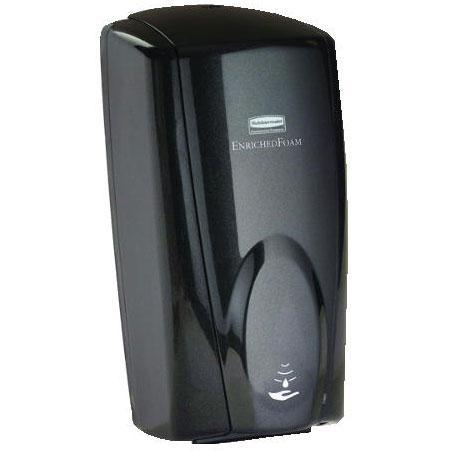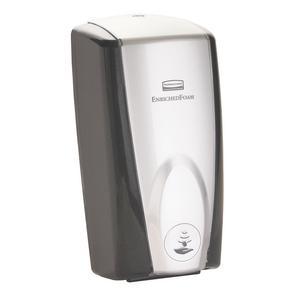The first image is the image on the left, the second image is the image on the right. Given the left and right images, does the statement "The left and right image contains the same number of wall hanging soap dispensers." hold true? Answer yes or no. Yes. The first image is the image on the left, the second image is the image on the right. For the images displayed, is the sentence "There are exactly two dispensers." factually correct? Answer yes or no. Yes. 